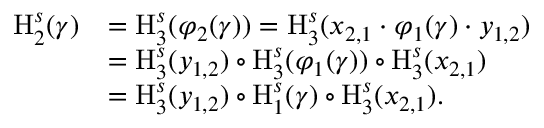Convert formula to latex. <formula><loc_0><loc_0><loc_500><loc_500>\begin{array} { r l } { H _ { 2 } ^ { s } ( \gamma ) } & { = H _ { 3 } ^ { s } ( \varphi _ { 2 } ( \gamma ) ) = H _ { 3 } ^ { s } ( x _ { 2 , 1 } \cdot \varphi _ { 1 } ( \gamma ) \cdot y _ { 1 , 2 } ) } \\ & { = H _ { 3 } ^ { s } ( y _ { 1 , 2 } ) \circ H _ { 3 } ^ { s } ( \varphi _ { 1 } ( \gamma ) ) \circ H _ { 3 } ^ { s } ( x _ { 2 , 1 } ) } \\ & { = H _ { 3 } ^ { s } ( y _ { 1 , 2 } ) \circ H _ { 1 } ^ { s } ( \gamma ) \circ H _ { 3 } ^ { s } ( x _ { 2 , 1 } ) . } \end{array}</formula> 